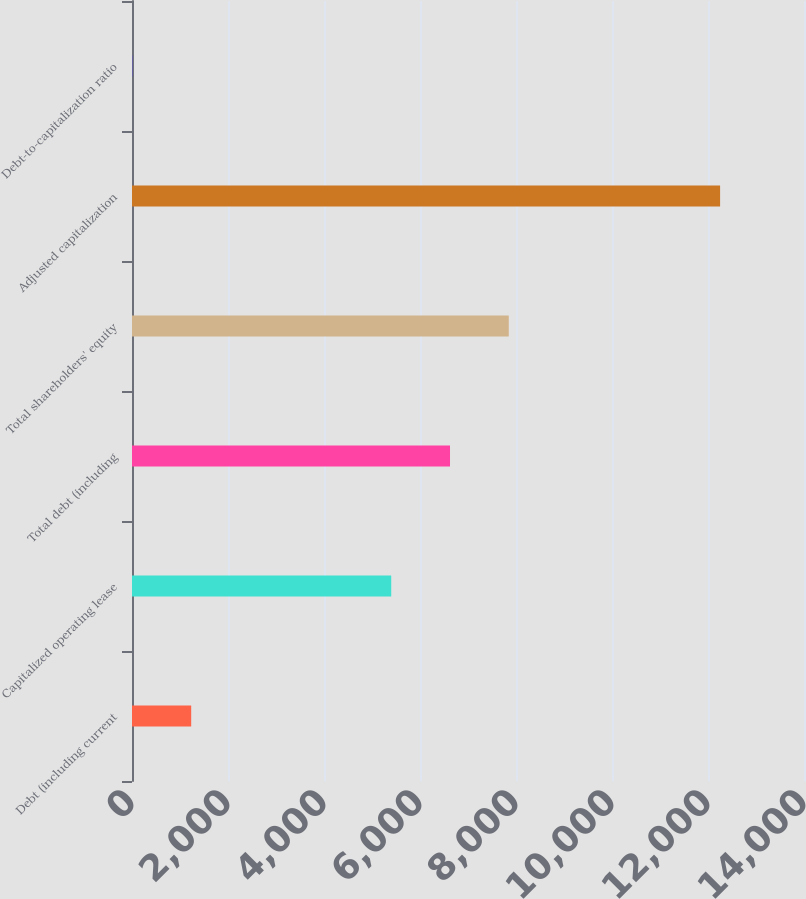<chart> <loc_0><loc_0><loc_500><loc_500><bar_chart><fcel>Debt (including current<fcel>Capitalized operating lease<fcel>Total debt (including<fcel>Total shareholders' equity<fcel>Adjusted capitalization<fcel>Debt-to-capitalization ratio<nl><fcel>1233.3<fcel>5401<fcel>6625.3<fcel>7849.6<fcel>12252<fcel>9<nl></chart> 